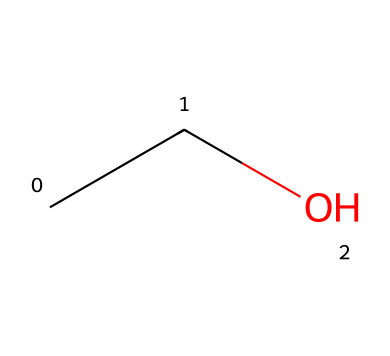How many carbon atoms are in this molecule? The SMILES representation "CCO" indicates two 'C' symbols, each representing a carbon atom. Therefore, there are two carbon atoms in ethanol.
Answer: 2 What is the common name of this chemical? The SMILES code "CCO" corresponds to ethanol, which is commonly known as alcohol used in beverages.
Answer: ethanol How many hydrogen atoms are present in this molecule? Each carbon typically forms four bonds. The two carbons each have bound hydrogens in addition to the oxygen. In total, the molecule has six hydrogen atoms: C2H6O.
Answer: 6 Is this chemical considered a flammable liquid? Ethanol, represented by "CCO", is known to be a flammable liquid due to its high volatility and the ability to ignite easily at room temperature.
Answer: yes What type of bonding is primarily present in ethanol? The molecule's structure reveals single bonds between carbon and oxygen (alkane), and between carbons (C-C), indicating it primarily contains covalent bonds.
Answer: covalent What is the functional group present in ethanol? The presence of the oxygen atom bonded to a carbon atom indicates that ethanol has a hydroxyl (-OH) functional group, which characterizes alcohols.
Answer: hydroxyl How many oxygen atoms are in this molecule? The SMILES representation includes one 'O', indicating the presence of a single oxygen atom in the ethanol molecule.
Answer: 1 